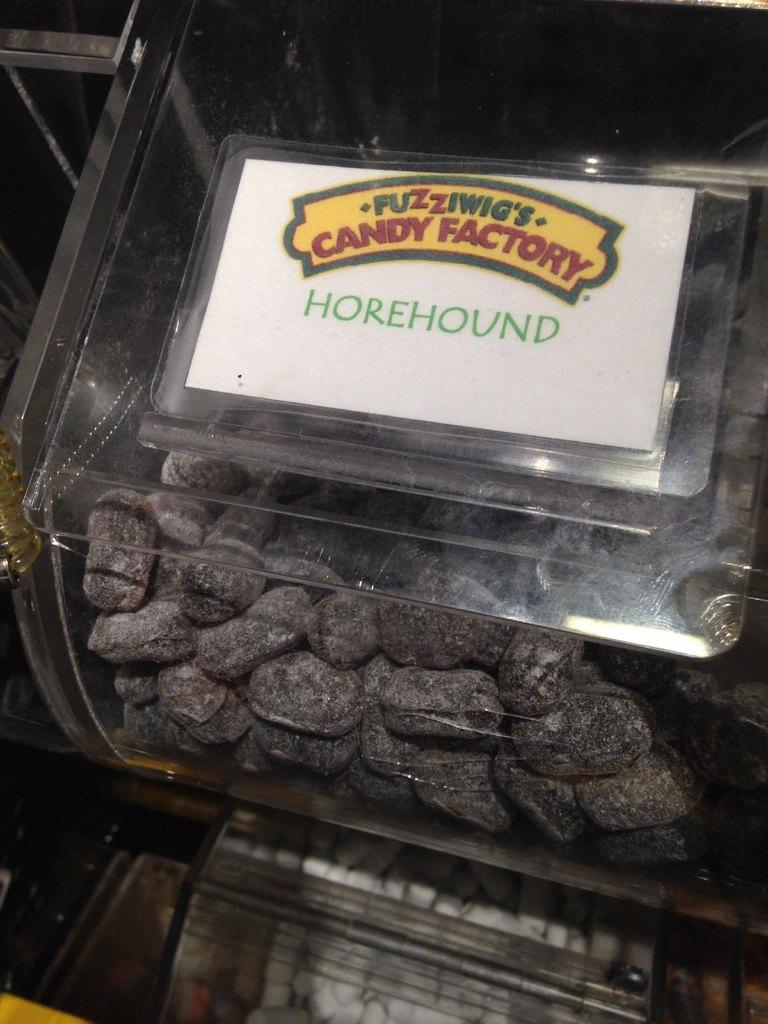What is the main subject of the image? There is a candy box in the center of the image. Can you describe the candy box in more detail? Unfortunately, the facts provided do not give any additional details about the candy box. Is there anything else in the image besides the candy box? The facts provided do not mention any other objects or subjects in the image. How many boys are playing with the chickens in the image? There are no boys or chickens present in the image; it only features a candy box. 